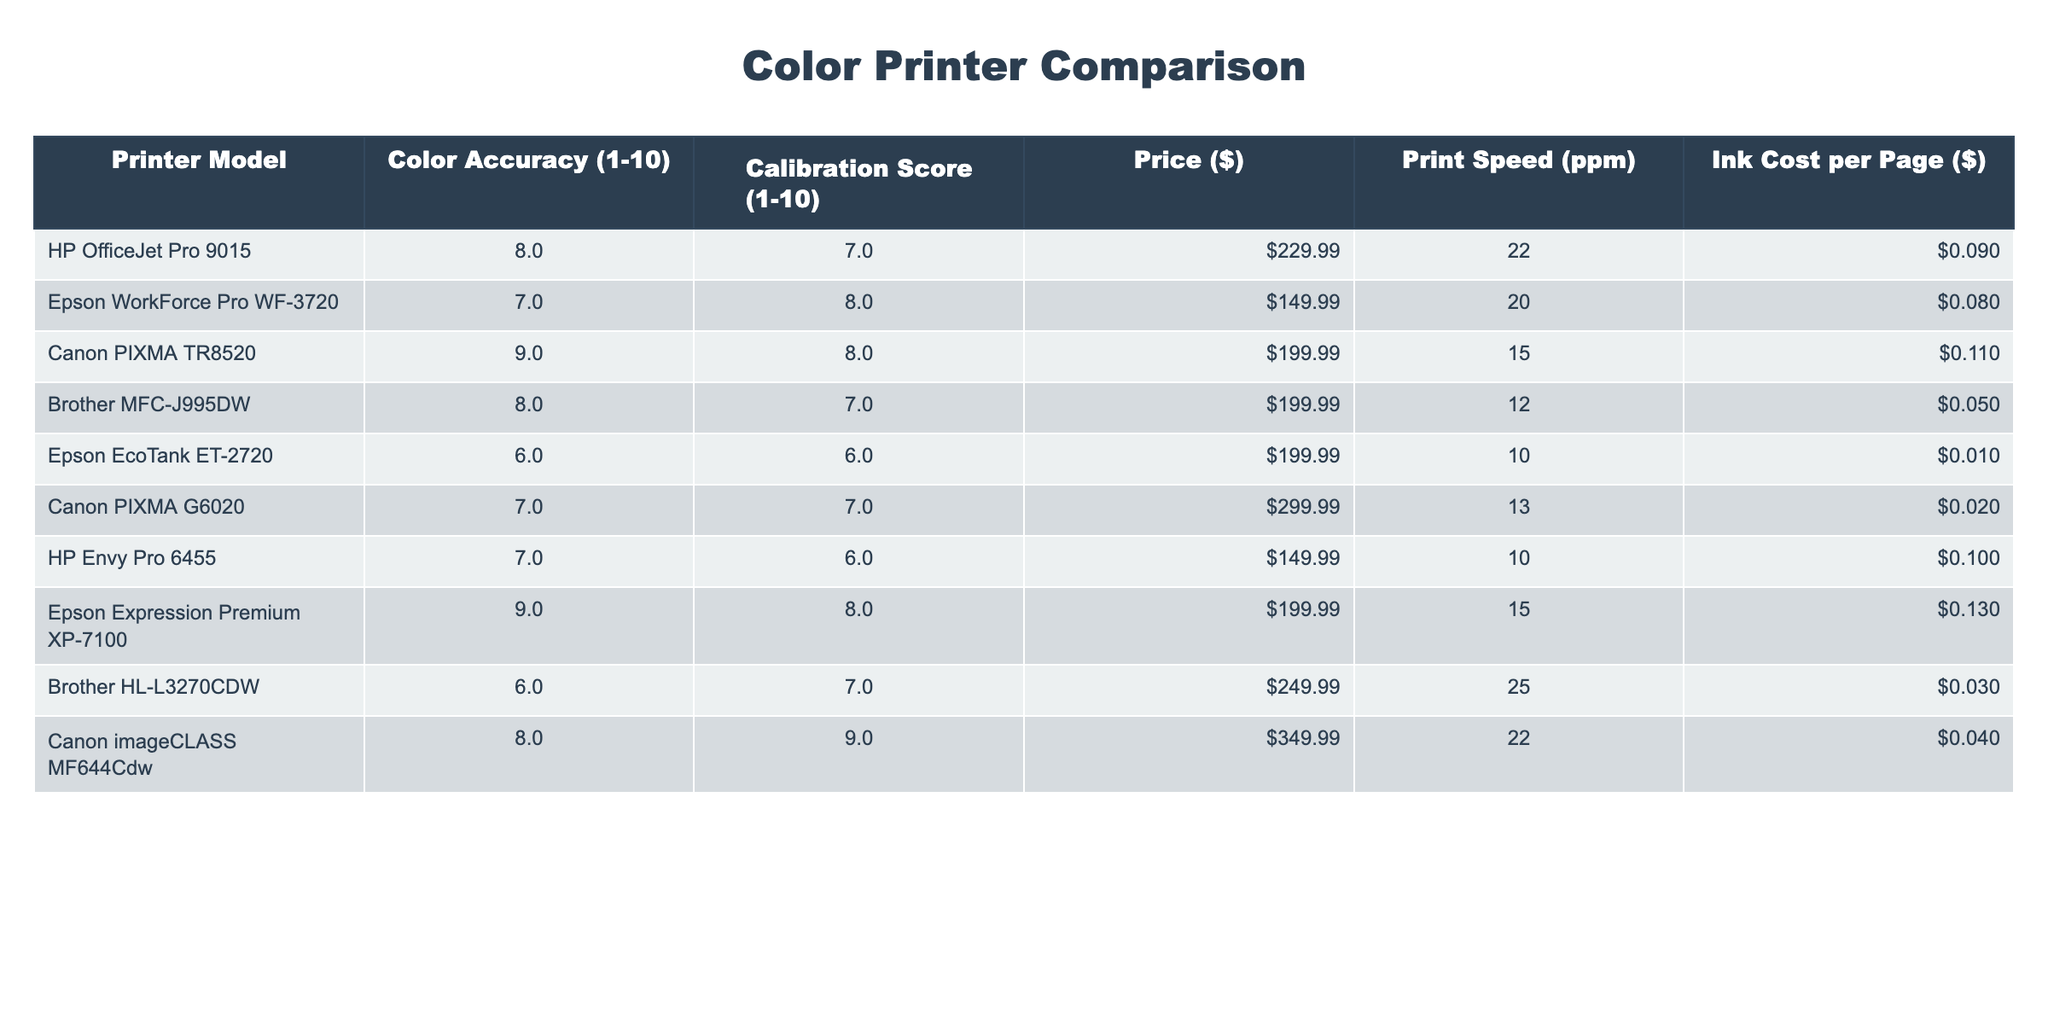What is the color accuracy score of the Canon PIXMA TR8520? The table lists the color accuracy score for each printer model. For the Canon PIXMA TR8520, the score is directly provided as 9.
Answer: 9 Which printer has the lowest ink cost per page? By comparing the ink costs per page for all models listed in the table, the Epson EcoTank ET-2720 has the lowest ink cost at $0.01 per page.
Answer: $0.01 What is the average price of printers with a color accuracy score of 8 or higher? The printers with a score of 8 or higher are HP OfficeJet Pro 9015, Canon PIXMA TR8520, Brother MFC-J995DW, Epson Expression Premium XP-7100, and Canon imageCLASS MF644Cdw. Their prices are $229.99, $199.99, $199.99, $199.99, and $349.99 respectively. The average price is calculated as (229.99 + 199.99 + 199.99 + 199.99 + 349.99) / 5 = 235.19.
Answer: $235.19 Is the Epson WorkForce Pro WF-3720 more color accurate than the Brother HL-L3270CDW? The color accuracy score for the Epson WorkForce Pro WF-3720 is 7, while for the Brother HL-L3270CDW it is 6. Since 7 is greater than 6, the Epson model is indeed more color accurate.
Answer: Yes Which printer model offers the best balance of print speed and color accuracy among those priced below $200? Looking at the printers priced below $200, we find the HP Envy Pro 6455 and Epson WorkForce Pro WF-3720, which both have color accuracy scores of 7. The HP Envy Pro has a print speed of 10 ppm, while the Epson has a speed of 20 ppm. Thus, the Epson provides a better balance with higher speed at the same accuracy score.
Answer: Epson WorkForce Pro WF-3720 What is the difference in calibration scores between the best and worst-rated printers? The best calibration score is 9 for the Canon imageCLASS MF644Cdw and the worst is 6 for the Epson EcoTank ET-2720 and HP Envy Pro 6455. The difference is calculated as 9 - 6 = 3.
Answer: 3 Which printer model is the most expensive, and what are its calibration and color accuracy scores? The Canon imageCLASS MF644Cdw is the most expensive at $349.99. Its calibration score is 9 and color accuracy score is 8 as per the table data.
Answer: Canon imageCLASS MF644Cdw; calibration score 9, color accuracy score 8 Are any printers with a price under $200 rated 9 for color accuracy? The only printers priced under $200 are HP Envy Pro 6455, Epson WorkForce Pro WF-3720, and Brother MFC-J995DW. None of these have a color accuracy score of 9; thus, the answer is no.
Answer: No What is the total print speed of all printers with a calibration score of 8? The printers with a calibration score of 8 are Canon PIXMA TR8520, Epson Expression Premium XP-7100, and Epson WorkForce Pro WF-3720. Their print speeds are 15 ppm, 15 ppm, and 20 ppm respectively. The total print speed is calculated as 15 + 15 + 20 = 50 ppm.
Answer: 50 ppm Which printer has a better price to color accuracy ratio: the Canon PIXMA TR8520 or the Epson EcoTank ET-2720? To find the ratio, we divide the price by the color accuracy score. The Canon PIXMA TR8520 has a ratio of 199.99/9 = 22.22, and the Epson EcoTank ET-2720 has a ratio of 199.99/6 = 33.33. Since 22.22 is less than 33.33, the Canon has a better ratio.
Answer: Canon PIXMA TR8520 